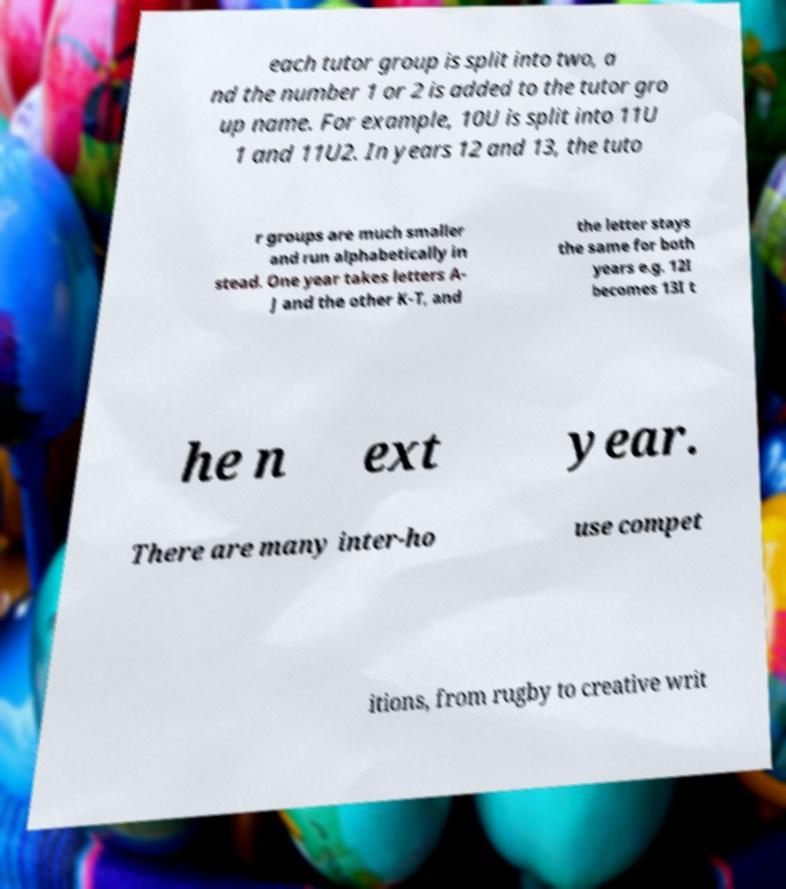Could you assist in decoding the text presented in this image and type it out clearly? each tutor group is split into two, a nd the number 1 or 2 is added to the tutor gro up name. For example, 10U is split into 11U 1 and 11U2. In years 12 and 13, the tuto r groups are much smaller and run alphabetically in stead. One year takes letters A- J and the other K-T, and the letter stays the same for both years e.g. 12I becomes 13I t he n ext year. There are many inter-ho use compet itions, from rugby to creative writ 